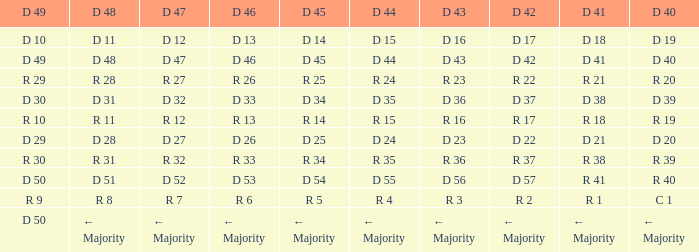I want the D 46 for D 45 of r 5 R 6. 